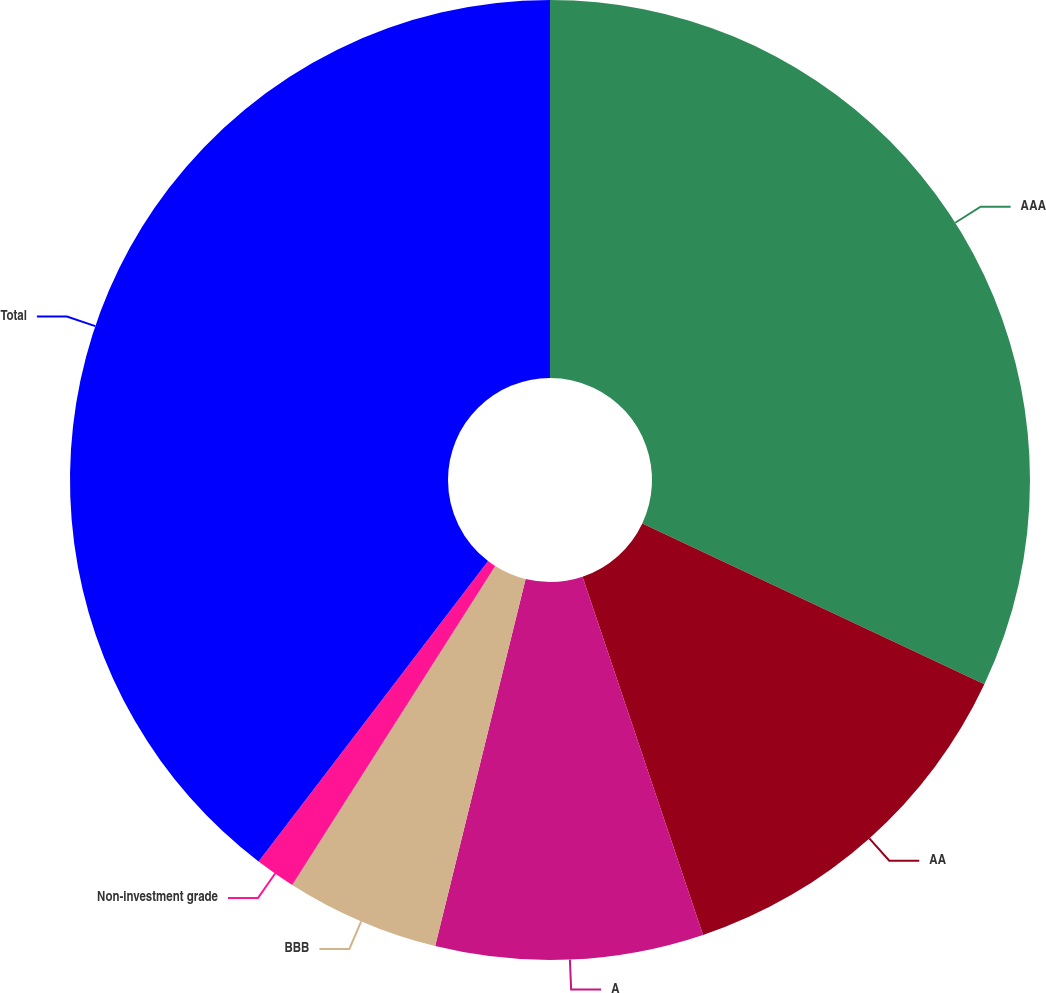Convert chart. <chart><loc_0><loc_0><loc_500><loc_500><pie_chart><fcel>AAA<fcel>AA<fcel>A<fcel>BBB<fcel>Non-investment grade<fcel>Total<nl><fcel>32.0%<fcel>12.84%<fcel>9.01%<fcel>5.18%<fcel>1.36%<fcel>39.62%<nl></chart> 